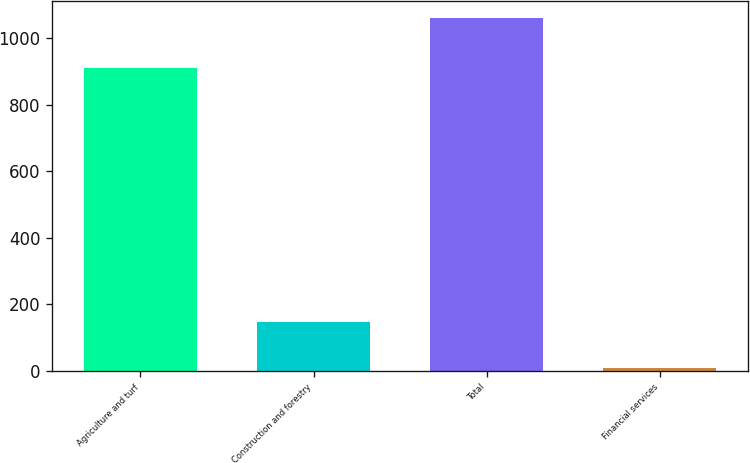Convert chart to OTSL. <chart><loc_0><loc_0><loc_500><loc_500><bar_chart><fcel>Agriculture and turf<fcel>Construction and forestry<fcel>Total<fcel>Financial services<nl><fcel>909<fcel>148<fcel>1059<fcel>8<nl></chart> 